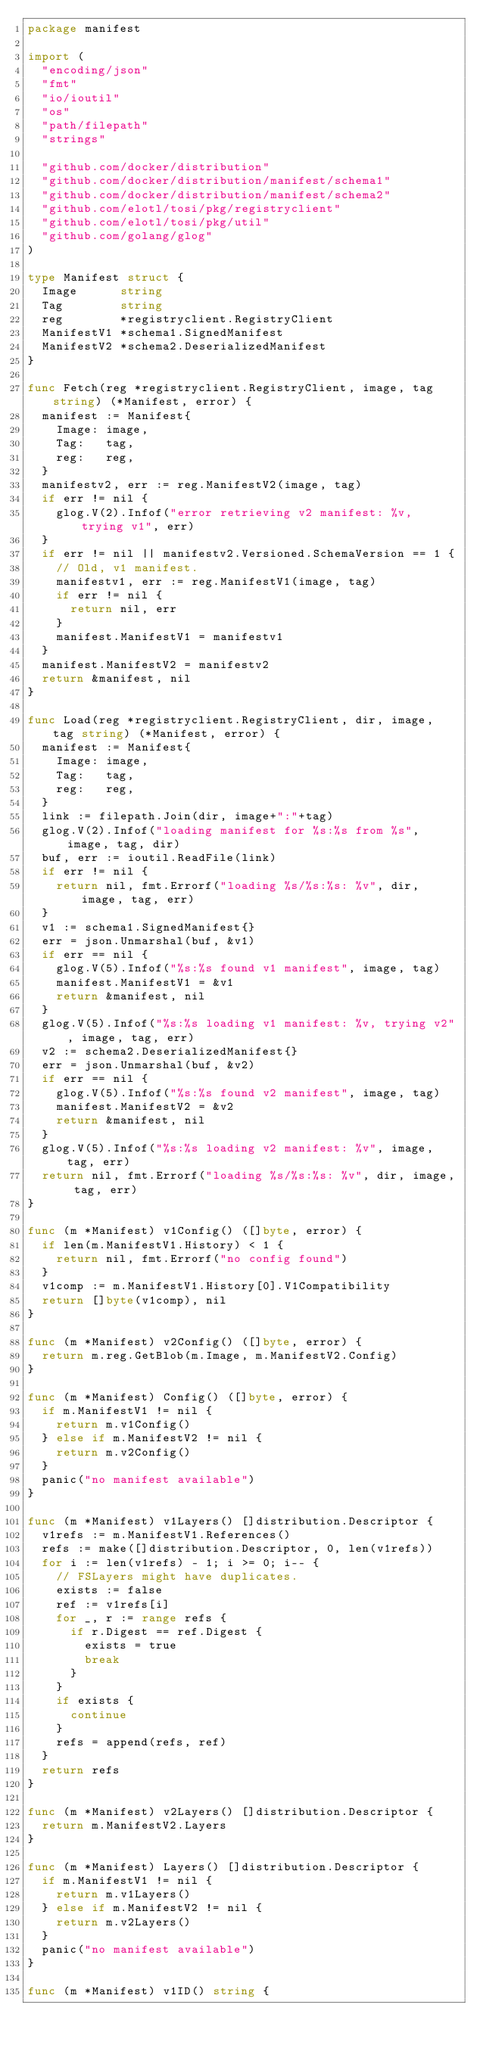Convert code to text. <code><loc_0><loc_0><loc_500><loc_500><_Go_>package manifest

import (
	"encoding/json"
	"fmt"
	"io/ioutil"
	"os"
	"path/filepath"
	"strings"

	"github.com/docker/distribution"
	"github.com/docker/distribution/manifest/schema1"
	"github.com/docker/distribution/manifest/schema2"
	"github.com/elotl/tosi/pkg/registryclient"
	"github.com/elotl/tosi/pkg/util"
	"github.com/golang/glog"
)

type Manifest struct {
	Image      string
	Tag        string
	reg        *registryclient.RegistryClient
	ManifestV1 *schema1.SignedManifest
	ManifestV2 *schema2.DeserializedManifest
}

func Fetch(reg *registryclient.RegistryClient, image, tag string) (*Manifest, error) {
	manifest := Manifest{
		Image: image,
		Tag:   tag,
		reg:   reg,
	}
	manifestv2, err := reg.ManifestV2(image, tag)
	if err != nil {
		glog.V(2).Infof("error retrieving v2 manifest: %v, trying v1", err)
	}
	if err != nil || manifestv2.Versioned.SchemaVersion == 1 {
		// Old, v1 manifest.
		manifestv1, err := reg.ManifestV1(image, tag)
		if err != nil {
			return nil, err
		}
		manifest.ManifestV1 = manifestv1
	}
	manifest.ManifestV2 = manifestv2
	return &manifest, nil
}

func Load(reg *registryclient.RegistryClient, dir, image, tag string) (*Manifest, error) {
	manifest := Manifest{
		Image: image,
		Tag:   tag,
		reg:   reg,
	}
	link := filepath.Join(dir, image+":"+tag)
	glog.V(2).Infof("loading manifest for %s:%s from %s", image, tag, dir)
	buf, err := ioutil.ReadFile(link)
	if err != nil {
		return nil, fmt.Errorf("loading %s/%s:%s: %v", dir, image, tag, err)
	}
	v1 := schema1.SignedManifest{}
	err = json.Unmarshal(buf, &v1)
	if err == nil {
		glog.V(5).Infof("%s:%s found v1 manifest", image, tag)
		manifest.ManifestV1 = &v1
		return &manifest, nil
	}
	glog.V(5).Infof("%s:%s loading v1 manifest: %v, trying v2", image, tag, err)
	v2 := schema2.DeserializedManifest{}
	err = json.Unmarshal(buf, &v2)
	if err == nil {
		glog.V(5).Infof("%s:%s found v2 manifest", image, tag)
		manifest.ManifestV2 = &v2
		return &manifest, nil
	}
	glog.V(5).Infof("%s:%s loading v2 manifest: %v", image, tag, err)
	return nil, fmt.Errorf("loading %s/%s:%s: %v", dir, image, tag, err)
}

func (m *Manifest) v1Config() ([]byte, error) {
	if len(m.ManifestV1.History) < 1 {
		return nil, fmt.Errorf("no config found")
	}
	v1comp := m.ManifestV1.History[0].V1Compatibility
	return []byte(v1comp), nil
}

func (m *Manifest) v2Config() ([]byte, error) {
	return m.reg.GetBlob(m.Image, m.ManifestV2.Config)
}

func (m *Manifest) Config() ([]byte, error) {
	if m.ManifestV1 != nil {
		return m.v1Config()
	} else if m.ManifestV2 != nil {
		return m.v2Config()
	}
	panic("no manifest available")
}

func (m *Manifest) v1Layers() []distribution.Descriptor {
	v1refs := m.ManifestV1.References()
	refs := make([]distribution.Descriptor, 0, len(v1refs))
	for i := len(v1refs) - 1; i >= 0; i-- {
		// FSLayers might have duplicates.
		exists := false
		ref := v1refs[i]
		for _, r := range refs {
			if r.Digest == ref.Digest {
				exists = true
				break
			}
		}
		if exists {
			continue
		}
		refs = append(refs, ref)
	}
	return refs
}

func (m *Manifest) v2Layers() []distribution.Descriptor {
	return m.ManifestV2.Layers
}

func (m *Manifest) Layers() []distribution.Descriptor {
	if m.ManifestV1 != nil {
		return m.v1Layers()
	} else if m.ManifestV2 != nil {
		return m.v2Layers()
	}
	panic("no manifest available")
}

func (m *Manifest) v1ID() string {</code> 